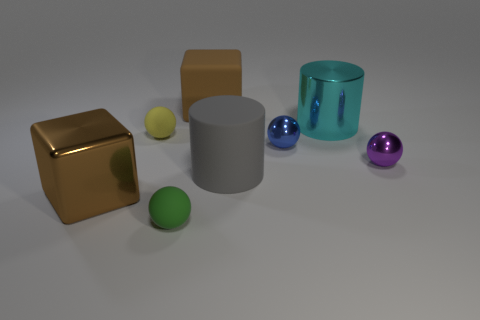Are there any yellow spheres of the same size as the matte cube? I can observe several spheres in the image, but there are no yellow spheres that match the size of the matte cube. The yellow sphere pictured is smaller than the cube. 